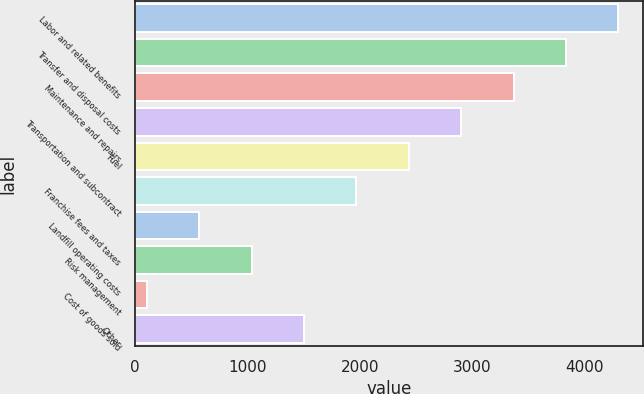Convert chart. <chart><loc_0><loc_0><loc_500><loc_500><bar_chart><fcel>Labor and related benefits<fcel>Transfer and disposal costs<fcel>Maintenance and repairs<fcel>Transportation and subcontract<fcel>Fuel<fcel>Franchise fees and taxes<fcel>Landfill operating costs<fcel>Risk management<fcel>Cost of goods sold<fcel>Other<nl><fcel>4298.71<fcel>3832.62<fcel>3366.53<fcel>2900.44<fcel>2434.35<fcel>1968.26<fcel>569.99<fcel>1036.08<fcel>103.9<fcel>1502.17<nl></chart> 